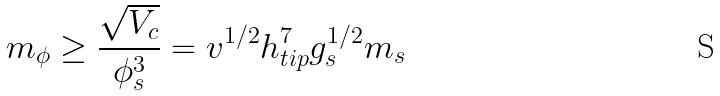<formula> <loc_0><loc_0><loc_500><loc_500>m _ { \phi } \geq \frac { \sqrt { V _ { c } } } { \phi _ { s } ^ { 3 } } = v ^ { 1 / 2 } h _ { t i p } ^ { 7 } g _ { s } ^ { 1 / 2 } m _ { s }</formula> 